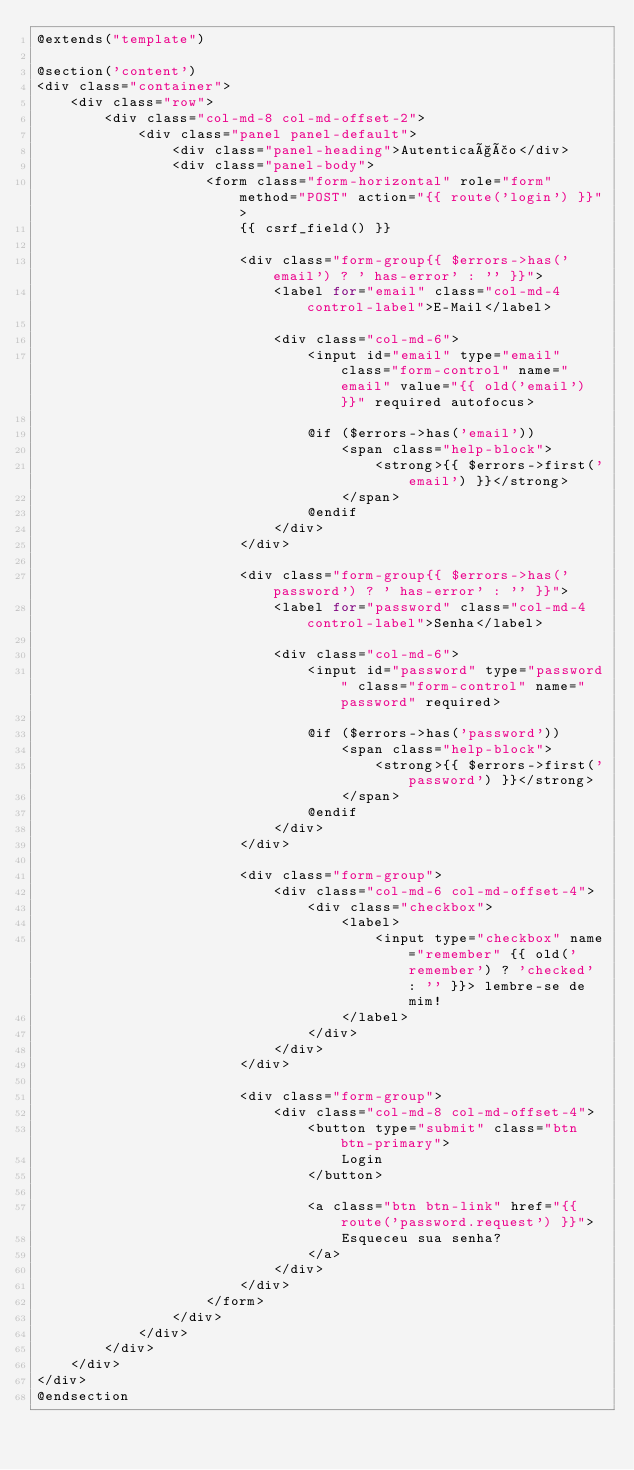Convert code to text. <code><loc_0><loc_0><loc_500><loc_500><_PHP_>@extends("template")

@section('content')
<div class="container">
    <div class="row">
        <div class="col-md-8 col-md-offset-2">
            <div class="panel panel-default">
                <div class="panel-heading">Autenticação</div>
                <div class="panel-body">
                    <form class="form-horizontal" role="form" method="POST" action="{{ route('login') }}">
                        {{ csrf_field() }}

                        <div class="form-group{{ $errors->has('email') ? ' has-error' : '' }}">
                            <label for="email" class="col-md-4 control-label">E-Mail</label>

                            <div class="col-md-6">
                                <input id="email" type="email" class="form-control" name="email" value="{{ old('email') }}" required autofocus>

                                @if ($errors->has('email'))
                                    <span class="help-block">
                                        <strong>{{ $errors->first('email') }}</strong>
                                    </span>
                                @endif
                            </div>
                        </div>

                        <div class="form-group{{ $errors->has('password') ? ' has-error' : '' }}">
                            <label for="password" class="col-md-4 control-label">Senha</label>

                            <div class="col-md-6">
                                <input id="password" type="password" class="form-control" name="password" required>

                                @if ($errors->has('password'))
                                    <span class="help-block">
                                        <strong>{{ $errors->first('password') }}</strong>
                                    </span>
                                @endif
                            </div>
                        </div>

                        <div class="form-group">
                            <div class="col-md-6 col-md-offset-4">
                                <div class="checkbox">
                                    <label>
                                        <input type="checkbox" name="remember" {{ old('remember') ? 'checked' : '' }}> lembre-se de mim!
                                    </label>
                                </div>
                            </div>
                        </div>

                        <div class="form-group">
                            <div class="col-md-8 col-md-offset-4">
                                <button type="submit" class="btn btn-primary">
                                    Login
                                </button>

                                <a class="btn btn-link" href="{{ route('password.request') }}">
                                    Esqueceu sua senha?
                                </a>
                            </div>
                        </div>
                    </form>
                </div>
            </div>
        </div>
    </div>
</div>
@endsection
</code> 